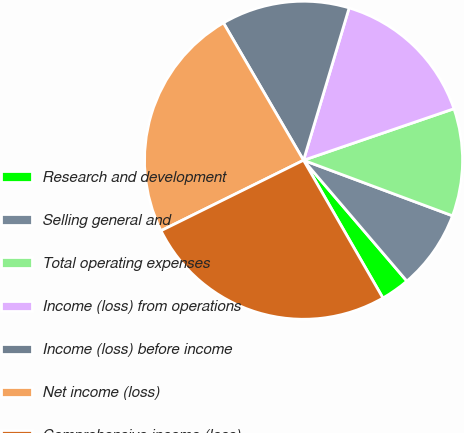Convert chart. <chart><loc_0><loc_0><loc_500><loc_500><pie_chart><fcel>Research and development<fcel>Selling general and<fcel>Total operating expenses<fcel>Income (loss) from operations<fcel>Income (loss) before income<fcel>Net income (loss)<fcel>Comprehensive income (loss)<nl><fcel>2.94%<fcel>8.06%<fcel>10.93%<fcel>15.12%<fcel>13.03%<fcel>23.91%<fcel>26.01%<nl></chart> 